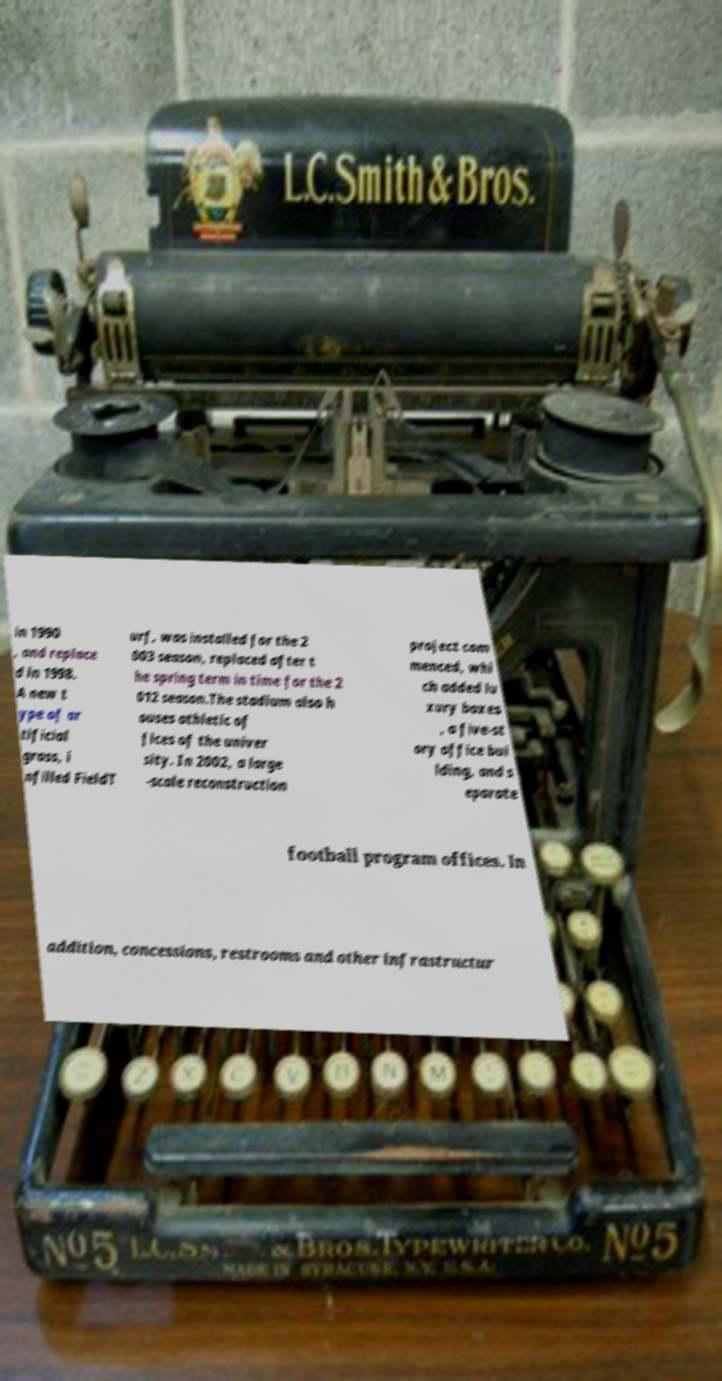Could you assist in decoding the text presented in this image and type it out clearly? in 1990 , and replace d in 1998. A new t ype of ar tificial grass, i nfilled FieldT urf, was installed for the 2 003 season, replaced after t he spring term in time for the 2 012 season.The stadium also h ouses athletic of fices of the univer sity. In 2002, a large -scale reconstruction project com menced, whi ch added lu xury boxes , a five-st ory office bui lding, and s eparate football program offices. In addition, concessions, restrooms and other infrastructur 